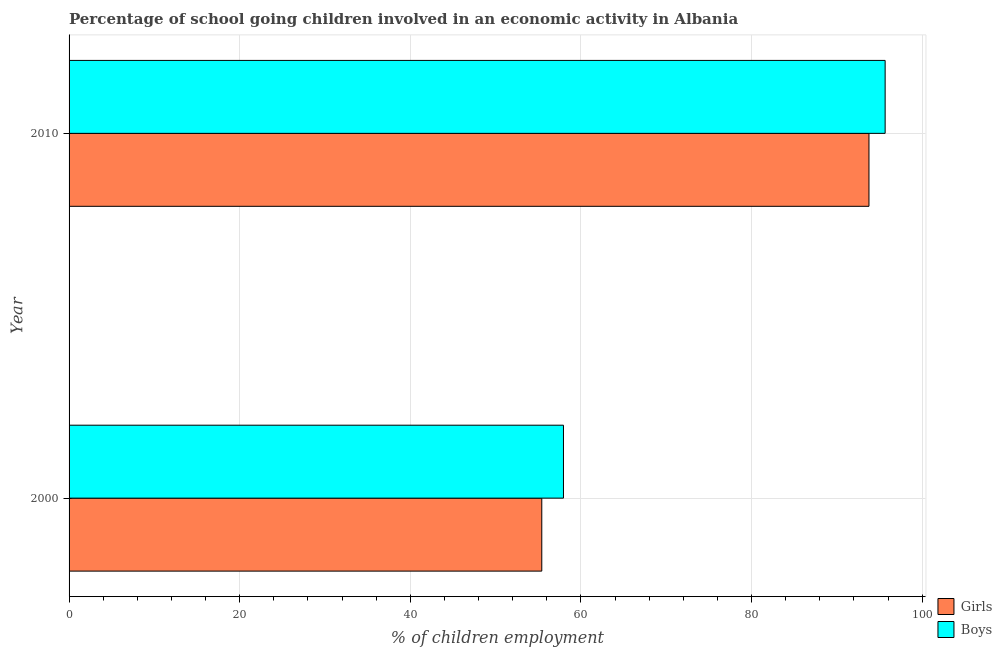How many different coloured bars are there?
Provide a short and direct response. 2. How many bars are there on the 2nd tick from the top?
Keep it short and to the point. 2. How many bars are there on the 2nd tick from the bottom?
Keep it short and to the point. 2. What is the label of the 1st group of bars from the top?
Keep it short and to the point. 2010. What is the percentage of school going girls in 2010?
Give a very brief answer. 93.76. Across all years, what is the maximum percentage of school going boys?
Your response must be concise. 95.65. Across all years, what is the minimum percentage of school going boys?
Provide a short and direct response. 57.95. In which year was the percentage of school going boys maximum?
Offer a very short reply. 2010. What is the total percentage of school going boys in the graph?
Make the answer very short. 153.6. What is the difference between the percentage of school going girls in 2000 and that in 2010?
Offer a very short reply. -38.35. What is the difference between the percentage of school going girls in 2010 and the percentage of school going boys in 2000?
Provide a short and direct response. 35.81. What is the average percentage of school going boys per year?
Provide a short and direct response. 76.8. In the year 2000, what is the difference between the percentage of school going girls and percentage of school going boys?
Your response must be concise. -2.54. What is the ratio of the percentage of school going girls in 2000 to that in 2010?
Provide a short and direct response. 0.59. Is the percentage of school going girls in 2000 less than that in 2010?
Provide a short and direct response. Yes. Is the difference between the percentage of school going girls in 2000 and 2010 greater than the difference between the percentage of school going boys in 2000 and 2010?
Your answer should be compact. No. What does the 1st bar from the top in 2000 represents?
Keep it short and to the point. Boys. What does the 2nd bar from the bottom in 2010 represents?
Give a very brief answer. Boys. How many bars are there?
Give a very brief answer. 4. Are all the bars in the graph horizontal?
Keep it short and to the point. Yes. How many years are there in the graph?
Offer a terse response. 2. Are the values on the major ticks of X-axis written in scientific E-notation?
Offer a terse response. No. Does the graph contain any zero values?
Keep it short and to the point. No. Where does the legend appear in the graph?
Offer a terse response. Bottom right. How many legend labels are there?
Offer a terse response. 2. How are the legend labels stacked?
Keep it short and to the point. Vertical. What is the title of the graph?
Offer a terse response. Percentage of school going children involved in an economic activity in Albania. What is the label or title of the X-axis?
Keep it short and to the point. % of children employment. What is the label or title of the Y-axis?
Give a very brief answer. Year. What is the % of children employment of Girls in 2000?
Ensure brevity in your answer.  55.41. What is the % of children employment of Boys in 2000?
Provide a short and direct response. 57.95. What is the % of children employment of Girls in 2010?
Your answer should be very brief. 93.76. What is the % of children employment of Boys in 2010?
Your response must be concise. 95.65. Across all years, what is the maximum % of children employment in Girls?
Ensure brevity in your answer.  93.76. Across all years, what is the maximum % of children employment of Boys?
Your answer should be very brief. 95.65. Across all years, what is the minimum % of children employment in Girls?
Ensure brevity in your answer.  55.41. Across all years, what is the minimum % of children employment in Boys?
Give a very brief answer. 57.95. What is the total % of children employment in Girls in the graph?
Your answer should be compact. 149.17. What is the total % of children employment of Boys in the graph?
Your answer should be very brief. 153.6. What is the difference between the % of children employment of Girls in 2000 and that in 2010?
Offer a terse response. -38.35. What is the difference between the % of children employment in Boys in 2000 and that in 2010?
Make the answer very short. -37.7. What is the difference between the % of children employment of Girls in 2000 and the % of children employment of Boys in 2010?
Offer a terse response. -40.24. What is the average % of children employment of Girls per year?
Keep it short and to the point. 74.58. What is the average % of children employment in Boys per year?
Give a very brief answer. 76.8. In the year 2000, what is the difference between the % of children employment in Girls and % of children employment in Boys?
Keep it short and to the point. -2.54. In the year 2010, what is the difference between the % of children employment of Girls and % of children employment of Boys?
Give a very brief answer. -1.89. What is the ratio of the % of children employment in Girls in 2000 to that in 2010?
Your answer should be very brief. 0.59. What is the ratio of the % of children employment in Boys in 2000 to that in 2010?
Make the answer very short. 0.61. What is the difference between the highest and the second highest % of children employment in Girls?
Offer a terse response. 38.35. What is the difference between the highest and the second highest % of children employment in Boys?
Your answer should be compact. 37.7. What is the difference between the highest and the lowest % of children employment in Girls?
Your answer should be compact. 38.35. What is the difference between the highest and the lowest % of children employment of Boys?
Make the answer very short. 37.7. 